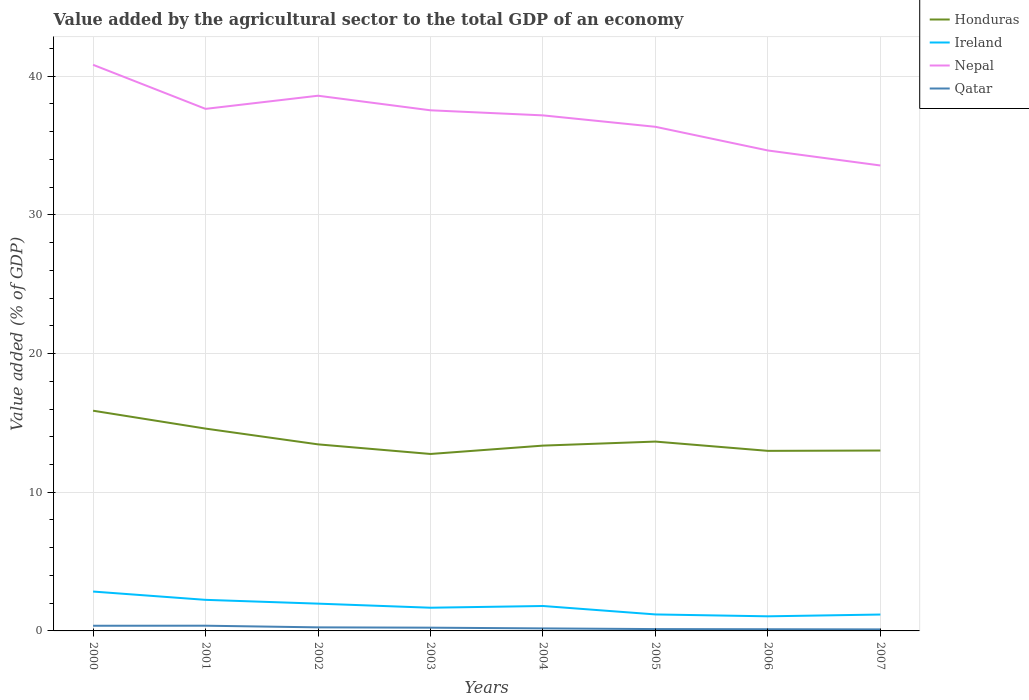How many different coloured lines are there?
Ensure brevity in your answer.  4. Does the line corresponding to Ireland intersect with the line corresponding to Nepal?
Your response must be concise. No. Is the number of lines equal to the number of legend labels?
Ensure brevity in your answer.  Yes. Across all years, what is the maximum value added by the agricultural sector to the total GDP in Ireland?
Provide a short and direct response. 1.05. In which year was the value added by the agricultural sector to the total GDP in Honduras maximum?
Keep it short and to the point. 2003. What is the total value added by the agricultural sector to the total GDP in Qatar in the graph?
Offer a terse response. 0.24. What is the difference between the highest and the second highest value added by the agricultural sector to the total GDP in Ireland?
Offer a terse response. 1.79. What is the difference between the highest and the lowest value added by the agricultural sector to the total GDP in Qatar?
Make the answer very short. 4. Is the value added by the agricultural sector to the total GDP in Honduras strictly greater than the value added by the agricultural sector to the total GDP in Ireland over the years?
Provide a short and direct response. No. How many lines are there?
Your answer should be very brief. 4. Where does the legend appear in the graph?
Make the answer very short. Top right. How are the legend labels stacked?
Offer a terse response. Vertical. What is the title of the graph?
Provide a succinct answer. Value added by the agricultural sector to the total GDP of an economy. What is the label or title of the Y-axis?
Make the answer very short. Value added (% of GDP). What is the Value added (% of GDP) of Honduras in 2000?
Offer a very short reply. 15.88. What is the Value added (% of GDP) in Ireland in 2000?
Make the answer very short. 2.84. What is the Value added (% of GDP) in Nepal in 2000?
Ensure brevity in your answer.  40.82. What is the Value added (% of GDP) in Qatar in 2000?
Offer a very short reply. 0.37. What is the Value added (% of GDP) in Honduras in 2001?
Offer a very short reply. 14.59. What is the Value added (% of GDP) of Ireland in 2001?
Provide a succinct answer. 2.24. What is the Value added (% of GDP) of Nepal in 2001?
Ensure brevity in your answer.  37.64. What is the Value added (% of GDP) in Qatar in 2001?
Ensure brevity in your answer.  0.38. What is the Value added (% of GDP) of Honduras in 2002?
Your answer should be compact. 13.45. What is the Value added (% of GDP) in Ireland in 2002?
Ensure brevity in your answer.  1.97. What is the Value added (% of GDP) in Nepal in 2002?
Give a very brief answer. 38.59. What is the Value added (% of GDP) in Qatar in 2002?
Provide a succinct answer. 0.26. What is the Value added (% of GDP) of Honduras in 2003?
Offer a terse response. 12.76. What is the Value added (% of GDP) of Ireland in 2003?
Offer a terse response. 1.67. What is the Value added (% of GDP) in Nepal in 2003?
Provide a short and direct response. 37.54. What is the Value added (% of GDP) of Qatar in 2003?
Offer a terse response. 0.23. What is the Value added (% of GDP) in Honduras in 2004?
Make the answer very short. 13.36. What is the Value added (% of GDP) in Ireland in 2004?
Offer a terse response. 1.8. What is the Value added (% of GDP) of Nepal in 2004?
Give a very brief answer. 37.17. What is the Value added (% of GDP) in Qatar in 2004?
Your answer should be compact. 0.18. What is the Value added (% of GDP) in Honduras in 2005?
Keep it short and to the point. 13.65. What is the Value added (% of GDP) in Ireland in 2005?
Your response must be concise. 1.19. What is the Value added (% of GDP) of Nepal in 2005?
Keep it short and to the point. 36.35. What is the Value added (% of GDP) in Qatar in 2005?
Provide a short and direct response. 0.13. What is the Value added (% of GDP) of Honduras in 2006?
Ensure brevity in your answer.  12.98. What is the Value added (% of GDP) in Ireland in 2006?
Offer a very short reply. 1.05. What is the Value added (% of GDP) in Nepal in 2006?
Offer a terse response. 34.64. What is the Value added (% of GDP) in Qatar in 2006?
Your answer should be very brief. 0.12. What is the Value added (% of GDP) of Honduras in 2007?
Provide a short and direct response. 13.01. What is the Value added (% of GDP) in Ireland in 2007?
Give a very brief answer. 1.18. What is the Value added (% of GDP) of Nepal in 2007?
Keep it short and to the point. 33.56. What is the Value added (% of GDP) in Qatar in 2007?
Your answer should be compact. 0.11. Across all years, what is the maximum Value added (% of GDP) in Honduras?
Provide a succinct answer. 15.88. Across all years, what is the maximum Value added (% of GDP) in Ireland?
Provide a short and direct response. 2.84. Across all years, what is the maximum Value added (% of GDP) of Nepal?
Ensure brevity in your answer.  40.82. Across all years, what is the maximum Value added (% of GDP) in Qatar?
Your response must be concise. 0.38. Across all years, what is the minimum Value added (% of GDP) in Honduras?
Give a very brief answer. 12.76. Across all years, what is the minimum Value added (% of GDP) of Ireland?
Your answer should be compact. 1.05. Across all years, what is the minimum Value added (% of GDP) of Nepal?
Offer a very short reply. 33.56. Across all years, what is the minimum Value added (% of GDP) of Qatar?
Provide a short and direct response. 0.11. What is the total Value added (% of GDP) of Honduras in the graph?
Your answer should be very brief. 109.68. What is the total Value added (% of GDP) of Ireland in the graph?
Offer a very short reply. 13.94. What is the total Value added (% of GDP) in Nepal in the graph?
Your answer should be compact. 296.32. What is the total Value added (% of GDP) in Qatar in the graph?
Keep it short and to the point. 1.79. What is the difference between the Value added (% of GDP) in Honduras in 2000 and that in 2001?
Provide a short and direct response. 1.29. What is the difference between the Value added (% of GDP) in Ireland in 2000 and that in 2001?
Provide a short and direct response. 0.6. What is the difference between the Value added (% of GDP) in Nepal in 2000 and that in 2001?
Keep it short and to the point. 3.18. What is the difference between the Value added (% of GDP) in Qatar in 2000 and that in 2001?
Your answer should be very brief. -0. What is the difference between the Value added (% of GDP) in Honduras in 2000 and that in 2002?
Ensure brevity in your answer.  2.43. What is the difference between the Value added (% of GDP) of Ireland in 2000 and that in 2002?
Ensure brevity in your answer.  0.87. What is the difference between the Value added (% of GDP) of Nepal in 2000 and that in 2002?
Give a very brief answer. 2.23. What is the difference between the Value added (% of GDP) in Qatar in 2000 and that in 2002?
Offer a very short reply. 0.12. What is the difference between the Value added (% of GDP) in Honduras in 2000 and that in 2003?
Your answer should be compact. 3.12. What is the difference between the Value added (% of GDP) of Ireland in 2000 and that in 2003?
Your answer should be very brief. 1.17. What is the difference between the Value added (% of GDP) of Nepal in 2000 and that in 2003?
Your response must be concise. 3.28. What is the difference between the Value added (% of GDP) of Qatar in 2000 and that in 2003?
Provide a succinct answer. 0.14. What is the difference between the Value added (% of GDP) of Honduras in 2000 and that in 2004?
Give a very brief answer. 2.52. What is the difference between the Value added (% of GDP) in Ireland in 2000 and that in 2004?
Offer a terse response. 1.04. What is the difference between the Value added (% of GDP) of Nepal in 2000 and that in 2004?
Provide a succinct answer. 3.65. What is the difference between the Value added (% of GDP) in Qatar in 2000 and that in 2004?
Provide a short and direct response. 0.19. What is the difference between the Value added (% of GDP) of Honduras in 2000 and that in 2005?
Ensure brevity in your answer.  2.23. What is the difference between the Value added (% of GDP) of Ireland in 2000 and that in 2005?
Ensure brevity in your answer.  1.65. What is the difference between the Value added (% of GDP) in Nepal in 2000 and that in 2005?
Your response must be concise. 4.47. What is the difference between the Value added (% of GDP) of Qatar in 2000 and that in 2005?
Ensure brevity in your answer.  0.24. What is the difference between the Value added (% of GDP) of Honduras in 2000 and that in 2006?
Make the answer very short. 2.9. What is the difference between the Value added (% of GDP) of Ireland in 2000 and that in 2006?
Your answer should be very brief. 1.79. What is the difference between the Value added (% of GDP) of Nepal in 2000 and that in 2006?
Your answer should be compact. 6.18. What is the difference between the Value added (% of GDP) of Qatar in 2000 and that in 2006?
Your answer should be compact. 0.25. What is the difference between the Value added (% of GDP) in Honduras in 2000 and that in 2007?
Your answer should be very brief. 2.87. What is the difference between the Value added (% of GDP) in Ireland in 2000 and that in 2007?
Keep it short and to the point. 1.66. What is the difference between the Value added (% of GDP) of Nepal in 2000 and that in 2007?
Ensure brevity in your answer.  7.26. What is the difference between the Value added (% of GDP) of Qatar in 2000 and that in 2007?
Your answer should be compact. 0.26. What is the difference between the Value added (% of GDP) in Honduras in 2001 and that in 2002?
Give a very brief answer. 1.14. What is the difference between the Value added (% of GDP) of Ireland in 2001 and that in 2002?
Provide a short and direct response. 0.27. What is the difference between the Value added (% of GDP) of Nepal in 2001 and that in 2002?
Make the answer very short. -0.95. What is the difference between the Value added (% of GDP) in Qatar in 2001 and that in 2002?
Provide a succinct answer. 0.12. What is the difference between the Value added (% of GDP) in Honduras in 2001 and that in 2003?
Provide a short and direct response. 1.83. What is the difference between the Value added (% of GDP) in Ireland in 2001 and that in 2003?
Offer a very short reply. 0.57. What is the difference between the Value added (% of GDP) of Nepal in 2001 and that in 2003?
Provide a succinct answer. 0.1. What is the difference between the Value added (% of GDP) of Qatar in 2001 and that in 2003?
Your answer should be compact. 0.14. What is the difference between the Value added (% of GDP) in Honduras in 2001 and that in 2004?
Give a very brief answer. 1.23. What is the difference between the Value added (% of GDP) in Ireland in 2001 and that in 2004?
Your answer should be very brief. 0.44. What is the difference between the Value added (% of GDP) in Nepal in 2001 and that in 2004?
Your answer should be compact. 0.47. What is the difference between the Value added (% of GDP) of Qatar in 2001 and that in 2004?
Your answer should be compact. 0.19. What is the difference between the Value added (% of GDP) of Honduras in 2001 and that in 2005?
Ensure brevity in your answer.  0.94. What is the difference between the Value added (% of GDP) in Ireland in 2001 and that in 2005?
Keep it short and to the point. 1.05. What is the difference between the Value added (% of GDP) of Nepal in 2001 and that in 2005?
Keep it short and to the point. 1.29. What is the difference between the Value added (% of GDP) in Qatar in 2001 and that in 2005?
Your answer should be compact. 0.24. What is the difference between the Value added (% of GDP) in Honduras in 2001 and that in 2006?
Ensure brevity in your answer.  1.61. What is the difference between the Value added (% of GDP) of Ireland in 2001 and that in 2006?
Give a very brief answer. 1.19. What is the difference between the Value added (% of GDP) of Nepal in 2001 and that in 2006?
Your answer should be very brief. 3. What is the difference between the Value added (% of GDP) in Qatar in 2001 and that in 2006?
Offer a very short reply. 0.25. What is the difference between the Value added (% of GDP) of Honduras in 2001 and that in 2007?
Provide a succinct answer. 1.58. What is the difference between the Value added (% of GDP) in Ireland in 2001 and that in 2007?
Offer a terse response. 1.06. What is the difference between the Value added (% of GDP) of Nepal in 2001 and that in 2007?
Give a very brief answer. 4.08. What is the difference between the Value added (% of GDP) of Qatar in 2001 and that in 2007?
Give a very brief answer. 0.27. What is the difference between the Value added (% of GDP) in Honduras in 2002 and that in 2003?
Your response must be concise. 0.69. What is the difference between the Value added (% of GDP) of Ireland in 2002 and that in 2003?
Your response must be concise. 0.29. What is the difference between the Value added (% of GDP) in Nepal in 2002 and that in 2003?
Provide a succinct answer. 1.05. What is the difference between the Value added (% of GDP) of Qatar in 2002 and that in 2003?
Your response must be concise. 0.02. What is the difference between the Value added (% of GDP) of Honduras in 2002 and that in 2004?
Ensure brevity in your answer.  0.09. What is the difference between the Value added (% of GDP) of Ireland in 2002 and that in 2004?
Offer a very short reply. 0.17. What is the difference between the Value added (% of GDP) in Nepal in 2002 and that in 2004?
Keep it short and to the point. 1.42. What is the difference between the Value added (% of GDP) in Qatar in 2002 and that in 2004?
Provide a succinct answer. 0.07. What is the difference between the Value added (% of GDP) in Honduras in 2002 and that in 2005?
Make the answer very short. -0.2. What is the difference between the Value added (% of GDP) of Ireland in 2002 and that in 2005?
Keep it short and to the point. 0.78. What is the difference between the Value added (% of GDP) in Nepal in 2002 and that in 2005?
Give a very brief answer. 2.24. What is the difference between the Value added (% of GDP) of Qatar in 2002 and that in 2005?
Ensure brevity in your answer.  0.12. What is the difference between the Value added (% of GDP) of Honduras in 2002 and that in 2006?
Provide a succinct answer. 0.47. What is the difference between the Value added (% of GDP) of Ireland in 2002 and that in 2006?
Offer a very short reply. 0.91. What is the difference between the Value added (% of GDP) of Nepal in 2002 and that in 2006?
Keep it short and to the point. 3.95. What is the difference between the Value added (% of GDP) in Qatar in 2002 and that in 2006?
Provide a short and direct response. 0.14. What is the difference between the Value added (% of GDP) in Honduras in 2002 and that in 2007?
Your answer should be very brief. 0.44. What is the difference between the Value added (% of GDP) of Ireland in 2002 and that in 2007?
Make the answer very short. 0.79. What is the difference between the Value added (% of GDP) in Nepal in 2002 and that in 2007?
Your response must be concise. 5.03. What is the difference between the Value added (% of GDP) of Qatar in 2002 and that in 2007?
Make the answer very short. 0.15. What is the difference between the Value added (% of GDP) of Honduras in 2003 and that in 2004?
Your answer should be very brief. -0.6. What is the difference between the Value added (% of GDP) of Ireland in 2003 and that in 2004?
Make the answer very short. -0.12. What is the difference between the Value added (% of GDP) of Nepal in 2003 and that in 2004?
Your answer should be compact. 0.37. What is the difference between the Value added (% of GDP) in Qatar in 2003 and that in 2004?
Your answer should be very brief. 0.05. What is the difference between the Value added (% of GDP) in Honduras in 2003 and that in 2005?
Your response must be concise. -0.89. What is the difference between the Value added (% of GDP) in Ireland in 2003 and that in 2005?
Give a very brief answer. 0.48. What is the difference between the Value added (% of GDP) in Nepal in 2003 and that in 2005?
Provide a short and direct response. 1.19. What is the difference between the Value added (% of GDP) of Qatar in 2003 and that in 2005?
Your answer should be very brief. 0.1. What is the difference between the Value added (% of GDP) of Honduras in 2003 and that in 2006?
Provide a short and direct response. -0.22. What is the difference between the Value added (% of GDP) in Ireland in 2003 and that in 2006?
Make the answer very short. 0.62. What is the difference between the Value added (% of GDP) in Nepal in 2003 and that in 2006?
Your answer should be compact. 2.9. What is the difference between the Value added (% of GDP) of Qatar in 2003 and that in 2006?
Your answer should be very brief. 0.11. What is the difference between the Value added (% of GDP) of Honduras in 2003 and that in 2007?
Keep it short and to the point. -0.25. What is the difference between the Value added (% of GDP) of Ireland in 2003 and that in 2007?
Provide a short and direct response. 0.49. What is the difference between the Value added (% of GDP) in Nepal in 2003 and that in 2007?
Offer a very short reply. 3.98. What is the difference between the Value added (% of GDP) of Qatar in 2003 and that in 2007?
Your answer should be very brief. 0.12. What is the difference between the Value added (% of GDP) in Honduras in 2004 and that in 2005?
Keep it short and to the point. -0.29. What is the difference between the Value added (% of GDP) of Ireland in 2004 and that in 2005?
Give a very brief answer. 0.61. What is the difference between the Value added (% of GDP) in Nepal in 2004 and that in 2005?
Ensure brevity in your answer.  0.82. What is the difference between the Value added (% of GDP) in Qatar in 2004 and that in 2005?
Provide a short and direct response. 0.05. What is the difference between the Value added (% of GDP) in Honduras in 2004 and that in 2006?
Ensure brevity in your answer.  0.38. What is the difference between the Value added (% of GDP) in Ireland in 2004 and that in 2006?
Your response must be concise. 0.74. What is the difference between the Value added (% of GDP) of Nepal in 2004 and that in 2006?
Keep it short and to the point. 2.53. What is the difference between the Value added (% of GDP) in Qatar in 2004 and that in 2006?
Offer a terse response. 0.06. What is the difference between the Value added (% of GDP) of Honduras in 2004 and that in 2007?
Offer a terse response. 0.35. What is the difference between the Value added (% of GDP) of Ireland in 2004 and that in 2007?
Offer a terse response. 0.62. What is the difference between the Value added (% of GDP) in Nepal in 2004 and that in 2007?
Give a very brief answer. 3.61. What is the difference between the Value added (% of GDP) in Qatar in 2004 and that in 2007?
Your response must be concise. 0.07. What is the difference between the Value added (% of GDP) of Honduras in 2005 and that in 2006?
Make the answer very short. 0.67. What is the difference between the Value added (% of GDP) in Ireland in 2005 and that in 2006?
Give a very brief answer. 0.14. What is the difference between the Value added (% of GDP) of Nepal in 2005 and that in 2006?
Provide a succinct answer. 1.71. What is the difference between the Value added (% of GDP) in Qatar in 2005 and that in 2006?
Provide a short and direct response. 0.01. What is the difference between the Value added (% of GDP) of Honduras in 2005 and that in 2007?
Ensure brevity in your answer.  0.65. What is the difference between the Value added (% of GDP) of Ireland in 2005 and that in 2007?
Offer a very short reply. 0.01. What is the difference between the Value added (% of GDP) in Nepal in 2005 and that in 2007?
Offer a terse response. 2.79. What is the difference between the Value added (% of GDP) in Qatar in 2005 and that in 2007?
Offer a very short reply. 0.02. What is the difference between the Value added (% of GDP) of Honduras in 2006 and that in 2007?
Make the answer very short. -0.02. What is the difference between the Value added (% of GDP) of Ireland in 2006 and that in 2007?
Your response must be concise. -0.13. What is the difference between the Value added (% of GDP) in Nepal in 2006 and that in 2007?
Offer a very short reply. 1.08. What is the difference between the Value added (% of GDP) in Qatar in 2006 and that in 2007?
Your answer should be very brief. 0.01. What is the difference between the Value added (% of GDP) in Honduras in 2000 and the Value added (% of GDP) in Ireland in 2001?
Provide a succinct answer. 13.64. What is the difference between the Value added (% of GDP) of Honduras in 2000 and the Value added (% of GDP) of Nepal in 2001?
Provide a succinct answer. -21.76. What is the difference between the Value added (% of GDP) of Honduras in 2000 and the Value added (% of GDP) of Qatar in 2001?
Offer a terse response. 15.5. What is the difference between the Value added (% of GDP) in Ireland in 2000 and the Value added (% of GDP) in Nepal in 2001?
Your answer should be very brief. -34.8. What is the difference between the Value added (% of GDP) in Ireland in 2000 and the Value added (% of GDP) in Qatar in 2001?
Your answer should be very brief. 2.46. What is the difference between the Value added (% of GDP) in Nepal in 2000 and the Value added (% of GDP) in Qatar in 2001?
Offer a terse response. 40.44. What is the difference between the Value added (% of GDP) in Honduras in 2000 and the Value added (% of GDP) in Ireland in 2002?
Make the answer very short. 13.91. What is the difference between the Value added (% of GDP) in Honduras in 2000 and the Value added (% of GDP) in Nepal in 2002?
Offer a very short reply. -22.71. What is the difference between the Value added (% of GDP) in Honduras in 2000 and the Value added (% of GDP) in Qatar in 2002?
Provide a short and direct response. 15.62. What is the difference between the Value added (% of GDP) in Ireland in 2000 and the Value added (% of GDP) in Nepal in 2002?
Give a very brief answer. -35.75. What is the difference between the Value added (% of GDP) of Ireland in 2000 and the Value added (% of GDP) of Qatar in 2002?
Provide a short and direct response. 2.58. What is the difference between the Value added (% of GDP) of Nepal in 2000 and the Value added (% of GDP) of Qatar in 2002?
Keep it short and to the point. 40.56. What is the difference between the Value added (% of GDP) of Honduras in 2000 and the Value added (% of GDP) of Ireland in 2003?
Provide a short and direct response. 14.21. What is the difference between the Value added (% of GDP) in Honduras in 2000 and the Value added (% of GDP) in Nepal in 2003?
Your answer should be compact. -21.66. What is the difference between the Value added (% of GDP) in Honduras in 2000 and the Value added (% of GDP) in Qatar in 2003?
Ensure brevity in your answer.  15.64. What is the difference between the Value added (% of GDP) in Ireland in 2000 and the Value added (% of GDP) in Nepal in 2003?
Make the answer very short. -34.7. What is the difference between the Value added (% of GDP) of Ireland in 2000 and the Value added (% of GDP) of Qatar in 2003?
Your response must be concise. 2.6. What is the difference between the Value added (% of GDP) in Nepal in 2000 and the Value added (% of GDP) in Qatar in 2003?
Your answer should be compact. 40.58. What is the difference between the Value added (% of GDP) of Honduras in 2000 and the Value added (% of GDP) of Ireland in 2004?
Ensure brevity in your answer.  14.08. What is the difference between the Value added (% of GDP) of Honduras in 2000 and the Value added (% of GDP) of Nepal in 2004?
Provide a short and direct response. -21.29. What is the difference between the Value added (% of GDP) in Honduras in 2000 and the Value added (% of GDP) in Qatar in 2004?
Your answer should be compact. 15.7. What is the difference between the Value added (% of GDP) of Ireland in 2000 and the Value added (% of GDP) of Nepal in 2004?
Provide a short and direct response. -34.33. What is the difference between the Value added (% of GDP) in Ireland in 2000 and the Value added (% of GDP) in Qatar in 2004?
Your response must be concise. 2.66. What is the difference between the Value added (% of GDP) of Nepal in 2000 and the Value added (% of GDP) of Qatar in 2004?
Provide a short and direct response. 40.64. What is the difference between the Value added (% of GDP) of Honduras in 2000 and the Value added (% of GDP) of Ireland in 2005?
Make the answer very short. 14.69. What is the difference between the Value added (% of GDP) of Honduras in 2000 and the Value added (% of GDP) of Nepal in 2005?
Provide a short and direct response. -20.47. What is the difference between the Value added (% of GDP) of Honduras in 2000 and the Value added (% of GDP) of Qatar in 2005?
Offer a terse response. 15.75. What is the difference between the Value added (% of GDP) in Ireland in 2000 and the Value added (% of GDP) in Nepal in 2005?
Your answer should be compact. -33.51. What is the difference between the Value added (% of GDP) of Ireland in 2000 and the Value added (% of GDP) of Qatar in 2005?
Provide a short and direct response. 2.71. What is the difference between the Value added (% of GDP) in Nepal in 2000 and the Value added (% of GDP) in Qatar in 2005?
Provide a succinct answer. 40.69. What is the difference between the Value added (% of GDP) of Honduras in 2000 and the Value added (% of GDP) of Ireland in 2006?
Your answer should be very brief. 14.83. What is the difference between the Value added (% of GDP) of Honduras in 2000 and the Value added (% of GDP) of Nepal in 2006?
Offer a very short reply. -18.76. What is the difference between the Value added (% of GDP) of Honduras in 2000 and the Value added (% of GDP) of Qatar in 2006?
Your response must be concise. 15.76. What is the difference between the Value added (% of GDP) in Ireland in 2000 and the Value added (% of GDP) in Nepal in 2006?
Ensure brevity in your answer.  -31.8. What is the difference between the Value added (% of GDP) in Ireland in 2000 and the Value added (% of GDP) in Qatar in 2006?
Offer a terse response. 2.72. What is the difference between the Value added (% of GDP) in Nepal in 2000 and the Value added (% of GDP) in Qatar in 2006?
Ensure brevity in your answer.  40.7. What is the difference between the Value added (% of GDP) of Honduras in 2000 and the Value added (% of GDP) of Ireland in 2007?
Provide a short and direct response. 14.7. What is the difference between the Value added (% of GDP) in Honduras in 2000 and the Value added (% of GDP) in Nepal in 2007?
Make the answer very short. -17.68. What is the difference between the Value added (% of GDP) in Honduras in 2000 and the Value added (% of GDP) in Qatar in 2007?
Provide a short and direct response. 15.77. What is the difference between the Value added (% of GDP) in Ireland in 2000 and the Value added (% of GDP) in Nepal in 2007?
Give a very brief answer. -30.72. What is the difference between the Value added (% of GDP) in Ireland in 2000 and the Value added (% of GDP) in Qatar in 2007?
Your answer should be compact. 2.73. What is the difference between the Value added (% of GDP) of Nepal in 2000 and the Value added (% of GDP) of Qatar in 2007?
Your answer should be very brief. 40.71. What is the difference between the Value added (% of GDP) of Honduras in 2001 and the Value added (% of GDP) of Ireland in 2002?
Ensure brevity in your answer.  12.62. What is the difference between the Value added (% of GDP) of Honduras in 2001 and the Value added (% of GDP) of Nepal in 2002?
Give a very brief answer. -24. What is the difference between the Value added (% of GDP) of Honduras in 2001 and the Value added (% of GDP) of Qatar in 2002?
Offer a terse response. 14.33. What is the difference between the Value added (% of GDP) of Ireland in 2001 and the Value added (% of GDP) of Nepal in 2002?
Offer a terse response. -36.35. What is the difference between the Value added (% of GDP) of Ireland in 2001 and the Value added (% of GDP) of Qatar in 2002?
Provide a succinct answer. 1.98. What is the difference between the Value added (% of GDP) in Nepal in 2001 and the Value added (% of GDP) in Qatar in 2002?
Make the answer very short. 37.39. What is the difference between the Value added (% of GDP) in Honduras in 2001 and the Value added (% of GDP) in Ireland in 2003?
Offer a terse response. 12.92. What is the difference between the Value added (% of GDP) of Honduras in 2001 and the Value added (% of GDP) of Nepal in 2003?
Keep it short and to the point. -22.95. What is the difference between the Value added (% of GDP) in Honduras in 2001 and the Value added (% of GDP) in Qatar in 2003?
Your answer should be very brief. 14.35. What is the difference between the Value added (% of GDP) of Ireland in 2001 and the Value added (% of GDP) of Nepal in 2003?
Provide a succinct answer. -35.3. What is the difference between the Value added (% of GDP) in Ireland in 2001 and the Value added (% of GDP) in Qatar in 2003?
Your answer should be very brief. 2.01. What is the difference between the Value added (% of GDP) of Nepal in 2001 and the Value added (% of GDP) of Qatar in 2003?
Make the answer very short. 37.41. What is the difference between the Value added (% of GDP) in Honduras in 2001 and the Value added (% of GDP) in Ireland in 2004?
Keep it short and to the point. 12.79. What is the difference between the Value added (% of GDP) in Honduras in 2001 and the Value added (% of GDP) in Nepal in 2004?
Provide a short and direct response. -22.58. What is the difference between the Value added (% of GDP) in Honduras in 2001 and the Value added (% of GDP) in Qatar in 2004?
Ensure brevity in your answer.  14.41. What is the difference between the Value added (% of GDP) in Ireland in 2001 and the Value added (% of GDP) in Nepal in 2004?
Your answer should be compact. -34.93. What is the difference between the Value added (% of GDP) in Ireland in 2001 and the Value added (% of GDP) in Qatar in 2004?
Ensure brevity in your answer.  2.06. What is the difference between the Value added (% of GDP) of Nepal in 2001 and the Value added (% of GDP) of Qatar in 2004?
Offer a very short reply. 37.46. What is the difference between the Value added (% of GDP) in Honduras in 2001 and the Value added (% of GDP) in Ireland in 2005?
Keep it short and to the point. 13.4. What is the difference between the Value added (% of GDP) in Honduras in 2001 and the Value added (% of GDP) in Nepal in 2005?
Provide a succinct answer. -21.76. What is the difference between the Value added (% of GDP) in Honduras in 2001 and the Value added (% of GDP) in Qatar in 2005?
Make the answer very short. 14.46. What is the difference between the Value added (% of GDP) in Ireland in 2001 and the Value added (% of GDP) in Nepal in 2005?
Offer a terse response. -34.11. What is the difference between the Value added (% of GDP) of Ireland in 2001 and the Value added (% of GDP) of Qatar in 2005?
Your answer should be very brief. 2.11. What is the difference between the Value added (% of GDP) of Nepal in 2001 and the Value added (% of GDP) of Qatar in 2005?
Keep it short and to the point. 37.51. What is the difference between the Value added (% of GDP) in Honduras in 2001 and the Value added (% of GDP) in Ireland in 2006?
Your response must be concise. 13.54. What is the difference between the Value added (% of GDP) of Honduras in 2001 and the Value added (% of GDP) of Nepal in 2006?
Your answer should be very brief. -20.05. What is the difference between the Value added (% of GDP) of Honduras in 2001 and the Value added (% of GDP) of Qatar in 2006?
Offer a terse response. 14.47. What is the difference between the Value added (% of GDP) of Ireland in 2001 and the Value added (% of GDP) of Nepal in 2006?
Offer a terse response. -32.4. What is the difference between the Value added (% of GDP) of Ireland in 2001 and the Value added (% of GDP) of Qatar in 2006?
Make the answer very short. 2.12. What is the difference between the Value added (% of GDP) in Nepal in 2001 and the Value added (% of GDP) in Qatar in 2006?
Provide a short and direct response. 37.52. What is the difference between the Value added (% of GDP) in Honduras in 2001 and the Value added (% of GDP) in Ireland in 2007?
Keep it short and to the point. 13.41. What is the difference between the Value added (% of GDP) of Honduras in 2001 and the Value added (% of GDP) of Nepal in 2007?
Keep it short and to the point. -18.97. What is the difference between the Value added (% of GDP) in Honduras in 2001 and the Value added (% of GDP) in Qatar in 2007?
Keep it short and to the point. 14.48. What is the difference between the Value added (% of GDP) of Ireland in 2001 and the Value added (% of GDP) of Nepal in 2007?
Ensure brevity in your answer.  -31.32. What is the difference between the Value added (% of GDP) in Ireland in 2001 and the Value added (% of GDP) in Qatar in 2007?
Your answer should be compact. 2.13. What is the difference between the Value added (% of GDP) in Nepal in 2001 and the Value added (% of GDP) in Qatar in 2007?
Give a very brief answer. 37.53. What is the difference between the Value added (% of GDP) of Honduras in 2002 and the Value added (% of GDP) of Ireland in 2003?
Give a very brief answer. 11.78. What is the difference between the Value added (% of GDP) of Honduras in 2002 and the Value added (% of GDP) of Nepal in 2003?
Make the answer very short. -24.09. What is the difference between the Value added (% of GDP) in Honduras in 2002 and the Value added (% of GDP) in Qatar in 2003?
Offer a very short reply. 13.22. What is the difference between the Value added (% of GDP) in Ireland in 2002 and the Value added (% of GDP) in Nepal in 2003?
Your answer should be compact. -35.57. What is the difference between the Value added (% of GDP) in Ireland in 2002 and the Value added (% of GDP) in Qatar in 2003?
Ensure brevity in your answer.  1.73. What is the difference between the Value added (% of GDP) of Nepal in 2002 and the Value added (% of GDP) of Qatar in 2003?
Ensure brevity in your answer.  38.36. What is the difference between the Value added (% of GDP) of Honduras in 2002 and the Value added (% of GDP) of Ireland in 2004?
Offer a very short reply. 11.65. What is the difference between the Value added (% of GDP) in Honduras in 2002 and the Value added (% of GDP) in Nepal in 2004?
Provide a short and direct response. -23.72. What is the difference between the Value added (% of GDP) of Honduras in 2002 and the Value added (% of GDP) of Qatar in 2004?
Your answer should be compact. 13.27. What is the difference between the Value added (% of GDP) in Ireland in 2002 and the Value added (% of GDP) in Nepal in 2004?
Give a very brief answer. -35.21. What is the difference between the Value added (% of GDP) of Ireland in 2002 and the Value added (% of GDP) of Qatar in 2004?
Ensure brevity in your answer.  1.79. What is the difference between the Value added (% of GDP) of Nepal in 2002 and the Value added (% of GDP) of Qatar in 2004?
Provide a short and direct response. 38.41. What is the difference between the Value added (% of GDP) of Honduras in 2002 and the Value added (% of GDP) of Ireland in 2005?
Provide a short and direct response. 12.26. What is the difference between the Value added (% of GDP) of Honduras in 2002 and the Value added (% of GDP) of Nepal in 2005?
Your answer should be compact. -22.9. What is the difference between the Value added (% of GDP) in Honduras in 2002 and the Value added (% of GDP) in Qatar in 2005?
Provide a short and direct response. 13.32. What is the difference between the Value added (% of GDP) in Ireland in 2002 and the Value added (% of GDP) in Nepal in 2005?
Provide a succinct answer. -34.38. What is the difference between the Value added (% of GDP) of Ireland in 2002 and the Value added (% of GDP) of Qatar in 2005?
Give a very brief answer. 1.83. What is the difference between the Value added (% of GDP) in Nepal in 2002 and the Value added (% of GDP) in Qatar in 2005?
Ensure brevity in your answer.  38.46. What is the difference between the Value added (% of GDP) in Honduras in 2002 and the Value added (% of GDP) in Ireland in 2006?
Offer a terse response. 12.4. What is the difference between the Value added (% of GDP) of Honduras in 2002 and the Value added (% of GDP) of Nepal in 2006?
Your response must be concise. -21.19. What is the difference between the Value added (% of GDP) in Honduras in 2002 and the Value added (% of GDP) in Qatar in 2006?
Provide a short and direct response. 13.33. What is the difference between the Value added (% of GDP) in Ireland in 2002 and the Value added (% of GDP) in Nepal in 2006?
Your response must be concise. -32.68. What is the difference between the Value added (% of GDP) of Ireland in 2002 and the Value added (% of GDP) of Qatar in 2006?
Your answer should be very brief. 1.85. What is the difference between the Value added (% of GDP) in Nepal in 2002 and the Value added (% of GDP) in Qatar in 2006?
Provide a succinct answer. 38.47. What is the difference between the Value added (% of GDP) of Honduras in 2002 and the Value added (% of GDP) of Ireland in 2007?
Your answer should be very brief. 12.27. What is the difference between the Value added (% of GDP) of Honduras in 2002 and the Value added (% of GDP) of Nepal in 2007?
Offer a very short reply. -20.11. What is the difference between the Value added (% of GDP) in Honduras in 2002 and the Value added (% of GDP) in Qatar in 2007?
Ensure brevity in your answer.  13.34. What is the difference between the Value added (% of GDP) of Ireland in 2002 and the Value added (% of GDP) of Nepal in 2007?
Make the answer very short. -31.59. What is the difference between the Value added (% of GDP) in Ireland in 2002 and the Value added (% of GDP) in Qatar in 2007?
Give a very brief answer. 1.86. What is the difference between the Value added (% of GDP) of Nepal in 2002 and the Value added (% of GDP) of Qatar in 2007?
Provide a succinct answer. 38.48. What is the difference between the Value added (% of GDP) of Honduras in 2003 and the Value added (% of GDP) of Ireland in 2004?
Offer a terse response. 10.96. What is the difference between the Value added (% of GDP) of Honduras in 2003 and the Value added (% of GDP) of Nepal in 2004?
Offer a very short reply. -24.41. What is the difference between the Value added (% of GDP) in Honduras in 2003 and the Value added (% of GDP) in Qatar in 2004?
Your answer should be very brief. 12.58. What is the difference between the Value added (% of GDP) in Ireland in 2003 and the Value added (% of GDP) in Nepal in 2004?
Offer a terse response. -35.5. What is the difference between the Value added (% of GDP) of Ireland in 2003 and the Value added (% of GDP) of Qatar in 2004?
Offer a very short reply. 1.49. What is the difference between the Value added (% of GDP) of Nepal in 2003 and the Value added (% of GDP) of Qatar in 2004?
Make the answer very short. 37.36. What is the difference between the Value added (% of GDP) in Honduras in 2003 and the Value added (% of GDP) in Ireland in 2005?
Provide a succinct answer. 11.57. What is the difference between the Value added (% of GDP) of Honduras in 2003 and the Value added (% of GDP) of Nepal in 2005?
Your answer should be very brief. -23.59. What is the difference between the Value added (% of GDP) of Honduras in 2003 and the Value added (% of GDP) of Qatar in 2005?
Your answer should be compact. 12.63. What is the difference between the Value added (% of GDP) in Ireland in 2003 and the Value added (% of GDP) in Nepal in 2005?
Offer a very short reply. -34.68. What is the difference between the Value added (% of GDP) of Ireland in 2003 and the Value added (% of GDP) of Qatar in 2005?
Your answer should be compact. 1.54. What is the difference between the Value added (% of GDP) of Nepal in 2003 and the Value added (% of GDP) of Qatar in 2005?
Your response must be concise. 37.41. What is the difference between the Value added (% of GDP) of Honduras in 2003 and the Value added (% of GDP) of Ireland in 2006?
Your response must be concise. 11.71. What is the difference between the Value added (% of GDP) of Honduras in 2003 and the Value added (% of GDP) of Nepal in 2006?
Give a very brief answer. -21.88. What is the difference between the Value added (% of GDP) of Honduras in 2003 and the Value added (% of GDP) of Qatar in 2006?
Offer a very short reply. 12.64. What is the difference between the Value added (% of GDP) in Ireland in 2003 and the Value added (% of GDP) in Nepal in 2006?
Your response must be concise. -32.97. What is the difference between the Value added (% of GDP) of Ireland in 2003 and the Value added (% of GDP) of Qatar in 2006?
Offer a very short reply. 1.55. What is the difference between the Value added (% of GDP) of Nepal in 2003 and the Value added (% of GDP) of Qatar in 2006?
Your answer should be compact. 37.42. What is the difference between the Value added (% of GDP) in Honduras in 2003 and the Value added (% of GDP) in Ireland in 2007?
Provide a succinct answer. 11.58. What is the difference between the Value added (% of GDP) in Honduras in 2003 and the Value added (% of GDP) in Nepal in 2007?
Make the answer very short. -20.8. What is the difference between the Value added (% of GDP) of Honduras in 2003 and the Value added (% of GDP) of Qatar in 2007?
Ensure brevity in your answer.  12.65. What is the difference between the Value added (% of GDP) of Ireland in 2003 and the Value added (% of GDP) of Nepal in 2007?
Offer a very short reply. -31.89. What is the difference between the Value added (% of GDP) in Ireland in 2003 and the Value added (% of GDP) in Qatar in 2007?
Offer a very short reply. 1.56. What is the difference between the Value added (% of GDP) of Nepal in 2003 and the Value added (% of GDP) of Qatar in 2007?
Your response must be concise. 37.43. What is the difference between the Value added (% of GDP) of Honduras in 2004 and the Value added (% of GDP) of Ireland in 2005?
Provide a succinct answer. 12.17. What is the difference between the Value added (% of GDP) in Honduras in 2004 and the Value added (% of GDP) in Nepal in 2005?
Provide a short and direct response. -22.99. What is the difference between the Value added (% of GDP) of Honduras in 2004 and the Value added (% of GDP) of Qatar in 2005?
Give a very brief answer. 13.23. What is the difference between the Value added (% of GDP) in Ireland in 2004 and the Value added (% of GDP) in Nepal in 2005?
Ensure brevity in your answer.  -34.55. What is the difference between the Value added (% of GDP) of Ireland in 2004 and the Value added (% of GDP) of Qatar in 2005?
Offer a very short reply. 1.66. What is the difference between the Value added (% of GDP) of Nepal in 2004 and the Value added (% of GDP) of Qatar in 2005?
Your response must be concise. 37.04. What is the difference between the Value added (% of GDP) of Honduras in 2004 and the Value added (% of GDP) of Ireland in 2006?
Offer a terse response. 12.31. What is the difference between the Value added (% of GDP) in Honduras in 2004 and the Value added (% of GDP) in Nepal in 2006?
Offer a terse response. -21.28. What is the difference between the Value added (% of GDP) of Honduras in 2004 and the Value added (% of GDP) of Qatar in 2006?
Keep it short and to the point. 13.24. What is the difference between the Value added (% of GDP) of Ireland in 2004 and the Value added (% of GDP) of Nepal in 2006?
Ensure brevity in your answer.  -32.84. What is the difference between the Value added (% of GDP) of Ireland in 2004 and the Value added (% of GDP) of Qatar in 2006?
Provide a short and direct response. 1.68. What is the difference between the Value added (% of GDP) in Nepal in 2004 and the Value added (% of GDP) in Qatar in 2006?
Offer a terse response. 37.05. What is the difference between the Value added (% of GDP) of Honduras in 2004 and the Value added (% of GDP) of Ireland in 2007?
Offer a terse response. 12.18. What is the difference between the Value added (% of GDP) of Honduras in 2004 and the Value added (% of GDP) of Nepal in 2007?
Offer a terse response. -20.2. What is the difference between the Value added (% of GDP) of Honduras in 2004 and the Value added (% of GDP) of Qatar in 2007?
Your answer should be compact. 13.25. What is the difference between the Value added (% of GDP) of Ireland in 2004 and the Value added (% of GDP) of Nepal in 2007?
Make the answer very short. -31.76. What is the difference between the Value added (% of GDP) of Ireland in 2004 and the Value added (% of GDP) of Qatar in 2007?
Your answer should be very brief. 1.69. What is the difference between the Value added (% of GDP) in Nepal in 2004 and the Value added (% of GDP) in Qatar in 2007?
Offer a very short reply. 37.06. What is the difference between the Value added (% of GDP) in Honduras in 2005 and the Value added (% of GDP) in Ireland in 2006?
Your response must be concise. 12.6. What is the difference between the Value added (% of GDP) in Honduras in 2005 and the Value added (% of GDP) in Nepal in 2006?
Your response must be concise. -20.99. What is the difference between the Value added (% of GDP) in Honduras in 2005 and the Value added (% of GDP) in Qatar in 2006?
Ensure brevity in your answer.  13.53. What is the difference between the Value added (% of GDP) of Ireland in 2005 and the Value added (% of GDP) of Nepal in 2006?
Your response must be concise. -33.45. What is the difference between the Value added (% of GDP) in Ireland in 2005 and the Value added (% of GDP) in Qatar in 2006?
Your response must be concise. 1.07. What is the difference between the Value added (% of GDP) of Nepal in 2005 and the Value added (% of GDP) of Qatar in 2006?
Your answer should be compact. 36.23. What is the difference between the Value added (% of GDP) of Honduras in 2005 and the Value added (% of GDP) of Ireland in 2007?
Your answer should be very brief. 12.47. What is the difference between the Value added (% of GDP) in Honduras in 2005 and the Value added (% of GDP) in Nepal in 2007?
Ensure brevity in your answer.  -19.91. What is the difference between the Value added (% of GDP) in Honduras in 2005 and the Value added (% of GDP) in Qatar in 2007?
Provide a short and direct response. 13.54. What is the difference between the Value added (% of GDP) in Ireland in 2005 and the Value added (% of GDP) in Nepal in 2007?
Give a very brief answer. -32.37. What is the difference between the Value added (% of GDP) in Ireland in 2005 and the Value added (% of GDP) in Qatar in 2007?
Ensure brevity in your answer.  1.08. What is the difference between the Value added (% of GDP) of Nepal in 2005 and the Value added (% of GDP) of Qatar in 2007?
Your answer should be compact. 36.24. What is the difference between the Value added (% of GDP) of Honduras in 2006 and the Value added (% of GDP) of Ireland in 2007?
Make the answer very short. 11.8. What is the difference between the Value added (% of GDP) of Honduras in 2006 and the Value added (% of GDP) of Nepal in 2007?
Provide a short and direct response. -20.58. What is the difference between the Value added (% of GDP) in Honduras in 2006 and the Value added (% of GDP) in Qatar in 2007?
Your response must be concise. 12.87. What is the difference between the Value added (% of GDP) in Ireland in 2006 and the Value added (% of GDP) in Nepal in 2007?
Keep it short and to the point. -32.51. What is the difference between the Value added (% of GDP) of Ireland in 2006 and the Value added (% of GDP) of Qatar in 2007?
Keep it short and to the point. 0.94. What is the difference between the Value added (% of GDP) of Nepal in 2006 and the Value added (% of GDP) of Qatar in 2007?
Offer a terse response. 34.53. What is the average Value added (% of GDP) of Honduras per year?
Make the answer very short. 13.71. What is the average Value added (% of GDP) of Ireland per year?
Your response must be concise. 1.74. What is the average Value added (% of GDP) of Nepal per year?
Offer a terse response. 37.04. What is the average Value added (% of GDP) in Qatar per year?
Offer a terse response. 0.22. In the year 2000, what is the difference between the Value added (% of GDP) of Honduras and Value added (% of GDP) of Ireland?
Your answer should be very brief. 13.04. In the year 2000, what is the difference between the Value added (% of GDP) in Honduras and Value added (% of GDP) in Nepal?
Your answer should be very brief. -24.94. In the year 2000, what is the difference between the Value added (% of GDP) in Honduras and Value added (% of GDP) in Qatar?
Your answer should be compact. 15.51. In the year 2000, what is the difference between the Value added (% of GDP) in Ireland and Value added (% of GDP) in Nepal?
Provide a short and direct response. -37.98. In the year 2000, what is the difference between the Value added (% of GDP) of Ireland and Value added (% of GDP) of Qatar?
Give a very brief answer. 2.47. In the year 2000, what is the difference between the Value added (% of GDP) of Nepal and Value added (% of GDP) of Qatar?
Offer a terse response. 40.45. In the year 2001, what is the difference between the Value added (% of GDP) of Honduras and Value added (% of GDP) of Ireland?
Provide a short and direct response. 12.35. In the year 2001, what is the difference between the Value added (% of GDP) of Honduras and Value added (% of GDP) of Nepal?
Give a very brief answer. -23.05. In the year 2001, what is the difference between the Value added (% of GDP) in Honduras and Value added (% of GDP) in Qatar?
Give a very brief answer. 14.21. In the year 2001, what is the difference between the Value added (% of GDP) of Ireland and Value added (% of GDP) of Nepal?
Your response must be concise. -35.4. In the year 2001, what is the difference between the Value added (% of GDP) in Ireland and Value added (% of GDP) in Qatar?
Provide a succinct answer. 1.86. In the year 2001, what is the difference between the Value added (% of GDP) in Nepal and Value added (% of GDP) in Qatar?
Your answer should be very brief. 37.27. In the year 2002, what is the difference between the Value added (% of GDP) in Honduras and Value added (% of GDP) in Ireland?
Provide a short and direct response. 11.48. In the year 2002, what is the difference between the Value added (% of GDP) in Honduras and Value added (% of GDP) in Nepal?
Make the answer very short. -25.14. In the year 2002, what is the difference between the Value added (% of GDP) of Honduras and Value added (% of GDP) of Qatar?
Offer a terse response. 13.2. In the year 2002, what is the difference between the Value added (% of GDP) of Ireland and Value added (% of GDP) of Nepal?
Make the answer very short. -36.62. In the year 2002, what is the difference between the Value added (% of GDP) in Ireland and Value added (% of GDP) in Qatar?
Your answer should be compact. 1.71. In the year 2002, what is the difference between the Value added (% of GDP) of Nepal and Value added (% of GDP) of Qatar?
Offer a very short reply. 38.33. In the year 2003, what is the difference between the Value added (% of GDP) in Honduras and Value added (% of GDP) in Ireland?
Your response must be concise. 11.09. In the year 2003, what is the difference between the Value added (% of GDP) in Honduras and Value added (% of GDP) in Nepal?
Give a very brief answer. -24.78. In the year 2003, what is the difference between the Value added (% of GDP) in Honduras and Value added (% of GDP) in Qatar?
Ensure brevity in your answer.  12.52. In the year 2003, what is the difference between the Value added (% of GDP) of Ireland and Value added (% of GDP) of Nepal?
Provide a succinct answer. -35.87. In the year 2003, what is the difference between the Value added (% of GDP) of Ireland and Value added (% of GDP) of Qatar?
Your response must be concise. 1.44. In the year 2003, what is the difference between the Value added (% of GDP) in Nepal and Value added (% of GDP) in Qatar?
Provide a succinct answer. 37.3. In the year 2004, what is the difference between the Value added (% of GDP) of Honduras and Value added (% of GDP) of Ireland?
Provide a succinct answer. 11.56. In the year 2004, what is the difference between the Value added (% of GDP) in Honduras and Value added (% of GDP) in Nepal?
Ensure brevity in your answer.  -23.81. In the year 2004, what is the difference between the Value added (% of GDP) of Honduras and Value added (% of GDP) of Qatar?
Provide a short and direct response. 13.18. In the year 2004, what is the difference between the Value added (% of GDP) in Ireland and Value added (% of GDP) in Nepal?
Make the answer very short. -35.38. In the year 2004, what is the difference between the Value added (% of GDP) of Ireland and Value added (% of GDP) of Qatar?
Offer a very short reply. 1.62. In the year 2004, what is the difference between the Value added (% of GDP) in Nepal and Value added (% of GDP) in Qatar?
Offer a terse response. 36.99. In the year 2005, what is the difference between the Value added (% of GDP) of Honduras and Value added (% of GDP) of Ireland?
Keep it short and to the point. 12.46. In the year 2005, what is the difference between the Value added (% of GDP) of Honduras and Value added (% of GDP) of Nepal?
Your answer should be very brief. -22.7. In the year 2005, what is the difference between the Value added (% of GDP) in Honduras and Value added (% of GDP) in Qatar?
Keep it short and to the point. 13.52. In the year 2005, what is the difference between the Value added (% of GDP) of Ireland and Value added (% of GDP) of Nepal?
Make the answer very short. -35.16. In the year 2005, what is the difference between the Value added (% of GDP) in Ireland and Value added (% of GDP) in Qatar?
Give a very brief answer. 1.06. In the year 2005, what is the difference between the Value added (% of GDP) of Nepal and Value added (% of GDP) of Qatar?
Offer a terse response. 36.22. In the year 2006, what is the difference between the Value added (% of GDP) of Honduras and Value added (% of GDP) of Ireland?
Offer a terse response. 11.93. In the year 2006, what is the difference between the Value added (% of GDP) in Honduras and Value added (% of GDP) in Nepal?
Offer a terse response. -21.66. In the year 2006, what is the difference between the Value added (% of GDP) of Honduras and Value added (% of GDP) of Qatar?
Your answer should be compact. 12.86. In the year 2006, what is the difference between the Value added (% of GDP) in Ireland and Value added (% of GDP) in Nepal?
Your response must be concise. -33.59. In the year 2006, what is the difference between the Value added (% of GDP) in Ireland and Value added (% of GDP) in Qatar?
Your response must be concise. 0.93. In the year 2006, what is the difference between the Value added (% of GDP) of Nepal and Value added (% of GDP) of Qatar?
Your answer should be compact. 34.52. In the year 2007, what is the difference between the Value added (% of GDP) of Honduras and Value added (% of GDP) of Ireland?
Make the answer very short. 11.83. In the year 2007, what is the difference between the Value added (% of GDP) in Honduras and Value added (% of GDP) in Nepal?
Your answer should be very brief. -20.55. In the year 2007, what is the difference between the Value added (% of GDP) of Honduras and Value added (% of GDP) of Qatar?
Give a very brief answer. 12.9. In the year 2007, what is the difference between the Value added (% of GDP) of Ireland and Value added (% of GDP) of Nepal?
Ensure brevity in your answer.  -32.38. In the year 2007, what is the difference between the Value added (% of GDP) of Ireland and Value added (% of GDP) of Qatar?
Offer a terse response. 1.07. In the year 2007, what is the difference between the Value added (% of GDP) of Nepal and Value added (% of GDP) of Qatar?
Give a very brief answer. 33.45. What is the ratio of the Value added (% of GDP) in Honduras in 2000 to that in 2001?
Provide a succinct answer. 1.09. What is the ratio of the Value added (% of GDP) in Ireland in 2000 to that in 2001?
Provide a short and direct response. 1.27. What is the ratio of the Value added (% of GDP) of Nepal in 2000 to that in 2001?
Provide a short and direct response. 1.08. What is the ratio of the Value added (% of GDP) in Honduras in 2000 to that in 2002?
Provide a succinct answer. 1.18. What is the ratio of the Value added (% of GDP) of Ireland in 2000 to that in 2002?
Offer a terse response. 1.44. What is the ratio of the Value added (% of GDP) in Nepal in 2000 to that in 2002?
Your answer should be compact. 1.06. What is the ratio of the Value added (% of GDP) of Qatar in 2000 to that in 2002?
Provide a short and direct response. 1.45. What is the ratio of the Value added (% of GDP) in Honduras in 2000 to that in 2003?
Your answer should be compact. 1.24. What is the ratio of the Value added (% of GDP) in Ireland in 2000 to that in 2003?
Offer a terse response. 1.7. What is the ratio of the Value added (% of GDP) in Nepal in 2000 to that in 2003?
Provide a succinct answer. 1.09. What is the ratio of the Value added (% of GDP) in Qatar in 2000 to that in 2003?
Your answer should be compact. 1.59. What is the ratio of the Value added (% of GDP) in Honduras in 2000 to that in 2004?
Ensure brevity in your answer.  1.19. What is the ratio of the Value added (% of GDP) of Ireland in 2000 to that in 2004?
Offer a very short reply. 1.58. What is the ratio of the Value added (% of GDP) of Nepal in 2000 to that in 2004?
Ensure brevity in your answer.  1.1. What is the ratio of the Value added (% of GDP) of Qatar in 2000 to that in 2004?
Give a very brief answer. 2.05. What is the ratio of the Value added (% of GDP) of Honduras in 2000 to that in 2005?
Your answer should be very brief. 1.16. What is the ratio of the Value added (% of GDP) in Ireland in 2000 to that in 2005?
Ensure brevity in your answer.  2.39. What is the ratio of the Value added (% of GDP) of Nepal in 2000 to that in 2005?
Provide a short and direct response. 1.12. What is the ratio of the Value added (% of GDP) in Qatar in 2000 to that in 2005?
Your answer should be compact. 2.8. What is the ratio of the Value added (% of GDP) in Honduras in 2000 to that in 2006?
Offer a terse response. 1.22. What is the ratio of the Value added (% of GDP) of Ireland in 2000 to that in 2006?
Provide a succinct answer. 2.7. What is the ratio of the Value added (% of GDP) of Nepal in 2000 to that in 2006?
Make the answer very short. 1.18. What is the ratio of the Value added (% of GDP) in Qatar in 2000 to that in 2006?
Offer a terse response. 3.06. What is the ratio of the Value added (% of GDP) of Honduras in 2000 to that in 2007?
Offer a terse response. 1.22. What is the ratio of the Value added (% of GDP) of Ireland in 2000 to that in 2007?
Offer a very short reply. 2.4. What is the ratio of the Value added (% of GDP) in Nepal in 2000 to that in 2007?
Offer a very short reply. 1.22. What is the ratio of the Value added (% of GDP) in Qatar in 2000 to that in 2007?
Keep it short and to the point. 3.39. What is the ratio of the Value added (% of GDP) of Honduras in 2001 to that in 2002?
Keep it short and to the point. 1.08. What is the ratio of the Value added (% of GDP) of Ireland in 2001 to that in 2002?
Ensure brevity in your answer.  1.14. What is the ratio of the Value added (% of GDP) of Nepal in 2001 to that in 2002?
Offer a terse response. 0.98. What is the ratio of the Value added (% of GDP) of Qatar in 2001 to that in 2002?
Make the answer very short. 1.46. What is the ratio of the Value added (% of GDP) in Honduras in 2001 to that in 2003?
Offer a very short reply. 1.14. What is the ratio of the Value added (% of GDP) in Ireland in 2001 to that in 2003?
Your answer should be compact. 1.34. What is the ratio of the Value added (% of GDP) of Nepal in 2001 to that in 2003?
Your response must be concise. 1. What is the ratio of the Value added (% of GDP) in Qatar in 2001 to that in 2003?
Your answer should be compact. 1.6. What is the ratio of the Value added (% of GDP) in Honduras in 2001 to that in 2004?
Provide a short and direct response. 1.09. What is the ratio of the Value added (% of GDP) in Ireland in 2001 to that in 2004?
Provide a short and direct response. 1.25. What is the ratio of the Value added (% of GDP) of Nepal in 2001 to that in 2004?
Your answer should be very brief. 1.01. What is the ratio of the Value added (% of GDP) of Qatar in 2001 to that in 2004?
Your answer should be compact. 2.07. What is the ratio of the Value added (% of GDP) of Honduras in 2001 to that in 2005?
Your answer should be very brief. 1.07. What is the ratio of the Value added (% of GDP) in Ireland in 2001 to that in 2005?
Make the answer very short. 1.88. What is the ratio of the Value added (% of GDP) in Nepal in 2001 to that in 2005?
Provide a succinct answer. 1.04. What is the ratio of the Value added (% of GDP) of Qatar in 2001 to that in 2005?
Keep it short and to the point. 2.82. What is the ratio of the Value added (% of GDP) in Honduras in 2001 to that in 2006?
Your answer should be very brief. 1.12. What is the ratio of the Value added (% of GDP) in Ireland in 2001 to that in 2006?
Offer a terse response. 2.13. What is the ratio of the Value added (% of GDP) in Nepal in 2001 to that in 2006?
Make the answer very short. 1.09. What is the ratio of the Value added (% of GDP) of Qatar in 2001 to that in 2006?
Offer a terse response. 3.09. What is the ratio of the Value added (% of GDP) in Honduras in 2001 to that in 2007?
Offer a very short reply. 1.12. What is the ratio of the Value added (% of GDP) in Ireland in 2001 to that in 2007?
Give a very brief answer. 1.9. What is the ratio of the Value added (% of GDP) in Nepal in 2001 to that in 2007?
Your answer should be compact. 1.12. What is the ratio of the Value added (% of GDP) in Qatar in 2001 to that in 2007?
Offer a very short reply. 3.42. What is the ratio of the Value added (% of GDP) of Honduras in 2002 to that in 2003?
Make the answer very short. 1.05. What is the ratio of the Value added (% of GDP) of Ireland in 2002 to that in 2003?
Offer a terse response. 1.18. What is the ratio of the Value added (% of GDP) of Nepal in 2002 to that in 2003?
Ensure brevity in your answer.  1.03. What is the ratio of the Value added (% of GDP) of Qatar in 2002 to that in 2003?
Ensure brevity in your answer.  1.09. What is the ratio of the Value added (% of GDP) in Honduras in 2002 to that in 2004?
Offer a terse response. 1.01. What is the ratio of the Value added (% of GDP) in Ireland in 2002 to that in 2004?
Provide a short and direct response. 1.09. What is the ratio of the Value added (% of GDP) in Nepal in 2002 to that in 2004?
Your answer should be very brief. 1.04. What is the ratio of the Value added (% of GDP) in Qatar in 2002 to that in 2004?
Your response must be concise. 1.41. What is the ratio of the Value added (% of GDP) in Honduras in 2002 to that in 2005?
Keep it short and to the point. 0.99. What is the ratio of the Value added (% of GDP) of Ireland in 2002 to that in 2005?
Your answer should be compact. 1.65. What is the ratio of the Value added (% of GDP) in Nepal in 2002 to that in 2005?
Offer a very short reply. 1.06. What is the ratio of the Value added (% of GDP) in Qatar in 2002 to that in 2005?
Offer a terse response. 1.93. What is the ratio of the Value added (% of GDP) in Honduras in 2002 to that in 2006?
Give a very brief answer. 1.04. What is the ratio of the Value added (% of GDP) of Ireland in 2002 to that in 2006?
Your answer should be compact. 1.87. What is the ratio of the Value added (% of GDP) of Nepal in 2002 to that in 2006?
Your answer should be very brief. 1.11. What is the ratio of the Value added (% of GDP) of Qatar in 2002 to that in 2006?
Your answer should be compact. 2.11. What is the ratio of the Value added (% of GDP) in Honduras in 2002 to that in 2007?
Offer a very short reply. 1.03. What is the ratio of the Value added (% of GDP) of Ireland in 2002 to that in 2007?
Your response must be concise. 1.67. What is the ratio of the Value added (% of GDP) of Nepal in 2002 to that in 2007?
Your answer should be compact. 1.15. What is the ratio of the Value added (% of GDP) in Qatar in 2002 to that in 2007?
Offer a terse response. 2.34. What is the ratio of the Value added (% of GDP) of Honduras in 2003 to that in 2004?
Provide a short and direct response. 0.95. What is the ratio of the Value added (% of GDP) of Ireland in 2003 to that in 2004?
Provide a succinct answer. 0.93. What is the ratio of the Value added (% of GDP) of Nepal in 2003 to that in 2004?
Keep it short and to the point. 1.01. What is the ratio of the Value added (% of GDP) in Qatar in 2003 to that in 2004?
Make the answer very short. 1.29. What is the ratio of the Value added (% of GDP) in Honduras in 2003 to that in 2005?
Give a very brief answer. 0.93. What is the ratio of the Value added (% of GDP) of Ireland in 2003 to that in 2005?
Ensure brevity in your answer.  1.41. What is the ratio of the Value added (% of GDP) of Nepal in 2003 to that in 2005?
Keep it short and to the point. 1.03. What is the ratio of the Value added (% of GDP) of Qatar in 2003 to that in 2005?
Provide a succinct answer. 1.76. What is the ratio of the Value added (% of GDP) in Honduras in 2003 to that in 2006?
Make the answer very short. 0.98. What is the ratio of the Value added (% of GDP) in Ireland in 2003 to that in 2006?
Your response must be concise. 1.59. What is the ratio of the Value added (% of GDP) of Nepal in 2003 to that in 2006?
Your answer should be very brief. 1.08. What is the ratio of the Value added (% of GDP) in Qatar in 2003 to that in 2006?
Offer a very short reply. 1.93. What is the ratio of the Value added (% of GDP) of Honduras in 2003 to that in 2007?
Offer a terse response. 0.98. What is the ratio of the Value added (% of GDP) in Ireland in 2003 to that in 2007?
Ensure brevity in your answer.  1.42. What is the ratio of the Value added (% of GDP) in Nepal in 2003 to that in 2007?
Ensure brevity in your answer.  1.12. What is the ratio of the Value added (% of GDP) in Qatar in 2003 to that in 2007?
Offer a terse response. 2.13. What is the ratio of the Value added (% of GDP) in Honduras in 2004 to that in 2005?
Make the answer very short. 0.98. What is the ratio of the Value added (% of GDP) of Ireland in 2004 to that in 2005?
Your answer should be very brief. 1.51. What is the ratio of the Value added (% of GDP) in Nepal in 2004 to that in 2005?
Provide a succinct answer. 1.02. What is the ratio of the Value added (% of GDP) in Qatar in 2004 to that in 2005?
Keep it short and to the point. 1.36. What is the ratio of the Value added (% of GDP) of Honduras in 2004 to that in 2006?
Provide a short and direct response. 1.03. What is the ratio of the Value added (% of GDP) of Ireland in 2004 to that in 2006?
Give a very brief answer. 1.71. What is the ratio of the Value added (% of GDP) of Nepal in 2004 to that in 2006?
Provide a succinct answer. 1.07. What is the ratio of the Value added (% of GDP) in Qatar in 2004 to that in 2006?
Ensure brevity in your answer.  1.49. What is the ratio of the Value added (% of GDP) in Honduras in 2004 to that in 2007?
Make the answer very short. 1.03. What is the ratio of the Value added (% of GDP) of Ireland in 2004 to that in 2007?
Your answer should be compact. 1.52. What is the ratio of the Value added (% of GDP) of Nepal in 2004 to that in 2007?
Offer a terse response. 1.11. What is the ratio of the Value added (% of GDP) in Qatar in 2004 to that in 2007?
Give a very brief answer. 1.65. What is the ratio of the Value added (% of GDP) in Honduras in 2005 to that in 2006?
Give a very brief answer. 1.05. What is the ratio of the Value added (% of GDP) in Ireland in 2005 to that in 2006?
Provide a succinct answer. 1.13. What is the ratio of the Value added (% of GDP) of Nepal in 2005 to that in 2006?
Provide a succinct answer. 1.05. What is the ratio of the Value added (% of GDP) in Qatar in 2005 to that in 2006?
Your answer should be very brief. 1.09. What is the ratio of the Value added (% of GDP) in Honduras in 2005 to that in 2007?
Make the answer very short. 1.05. What is the ratio of the Value added (% of GDP) of Ireland in 2005 to that in 2007?
Your answer should be compact. 1.01. What is the ratio of the Value added (% of GDP) of Nepal in 2005 to that in 2007?
Offer a very short reply. 1.08. What is the ratio of the Value added (% of GDP) in Qatar in 2005 to that in 2007?
Ensure brevity in your answer.  1.21. What is the ratio of the Value added (% of GDP) of Honduras in 2006 to that in 2007?
Offer a terse response. 1. What is the ratio of the Value added (% of GDP) of Ireland in 2006 to that in 2007?
Provide a succinct answer. 0.89. What is the ratio of the Value added (% of GDP) of Nepal in 2006 to that in 2007?
Provide a succinct answer. 1.03. What is the ratio of the Value added (% of GDP) in Qatar in 2006 to that in 2007?
Your answer should be very brief. 1.11. What is the difference between the highest and the second highest Value added (% of GDP) of Honduras?
Ensure brevity in your answer.  1.29. What is the difference between the highest and the second highest Value added (% of GDP) in Ireland?
Your answer should be compact. 0.6. What is the difference between the highest and the second highest Value added (% of GDP) of Nepal?
Your answer should be very brief. 2.23. What is the difference between the highest and the second highest Value added (% of GDP) of Qatar?
Your answer should be very brief. 0. What is the difference between the highest and the lowest Value added (% of GDP) in Honduras?
Offer a very short reply. 3.12. What is the difference between the highest and the lowest Value added (% of GDP) of Ireland?
Your answer should be compact. 1.79. What is the difference between the highest and the lowest Value added (% of GDP) in Nepal?
Give a very brief answer. 7.26. What is the difference between the highest and the lowest Value added (% of GDP) in Qatar?
Provide a succinct answer. 0.27. 